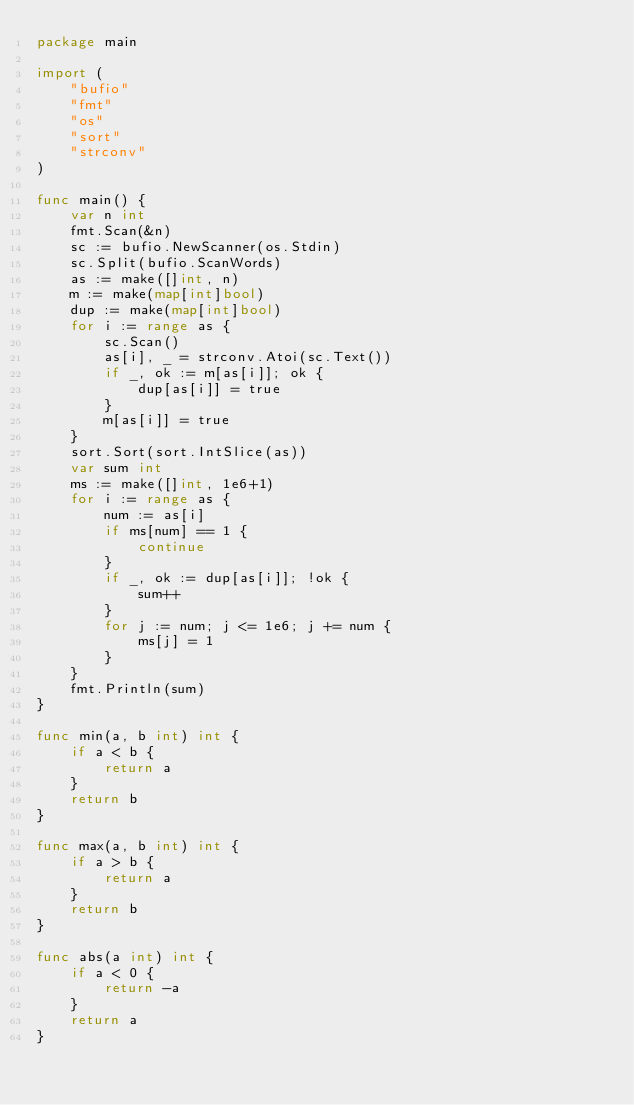Convert code to text. <code><loc_0><loc_0><loc_500><loc_500><_Go_>package main

import (
	"bufio"
	"fmt"
	"os"
	"sort"
	"strconv"
)

func main() {
	var n int
	fmt.Scan(&n)
	sc := bufio.NewScanner(os.Stdin)
	sc.Split(bufio.ScanWords)
	as := make([]int, n)
	m := make(map[int]bool)
	dup := make(map[int]bool)
	for i := range as {
		sc.Scan()
		as[i], _ = strconv.Atoi(sc.Text())
		if _, ok := m[as[i]]; ok {
			dup[as[i]] = true
		}
		m[as[i]] = true
	}
	sort.Sort(sort.IntSlice(as))
	var sum int
	ms := make([]int, 1e6+1)
	for i := range as {
		num := as[i]
		if ms[num] == 1 {
			continue
		}
		if _, ok := dup[as[i]]; !ok {
			sum++
		}
		for j := num; j <= 1e6; j += num {
			ms[j] = 1
		}
	}
	fmt.Println(sum)
}

func min(a, b int) int {
	if a < b {
		return a
	}
	return b
}

func max(a, b int) int {
	if a > b {
		return a
	}
	return b
}

func abs(a int) int {
	if a < 0 {
		return -a
	}
	return a
}
</code> 